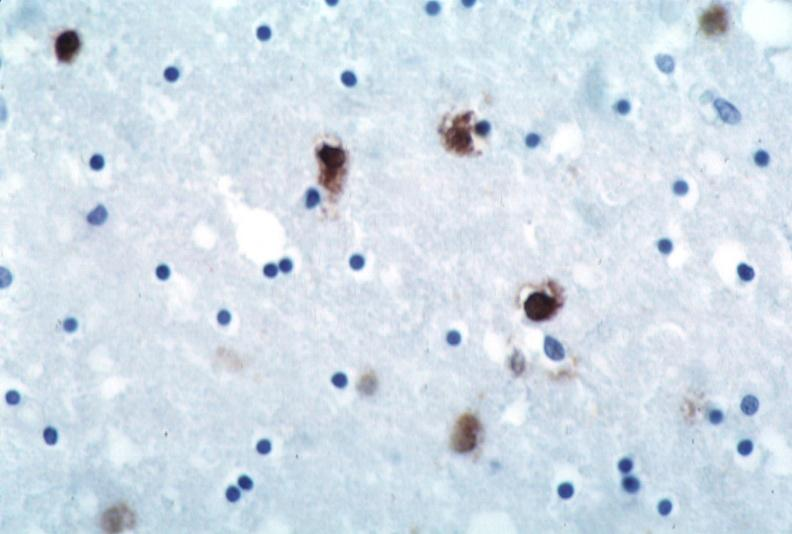does this image show brain, herpes encephalitis?
Answer the question using a single word or phrase. Yes 